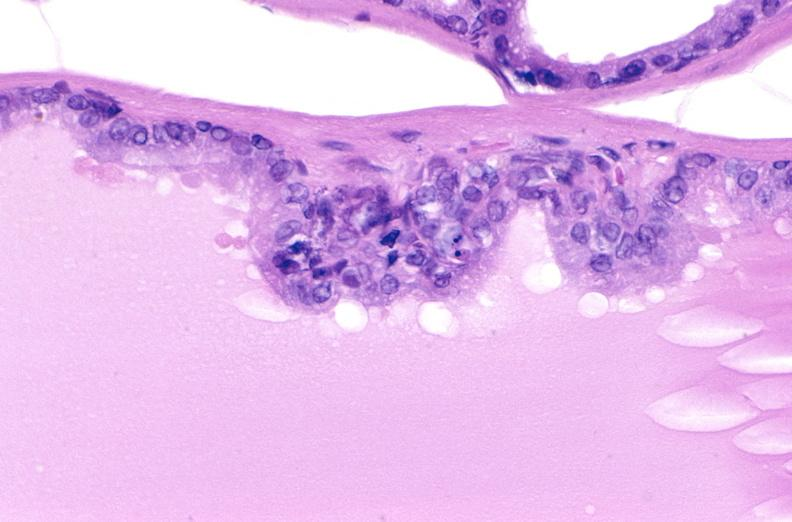what does this image show?
Answer the question using a single word or phrase. Apoptosis in prostate after orchiectomy 